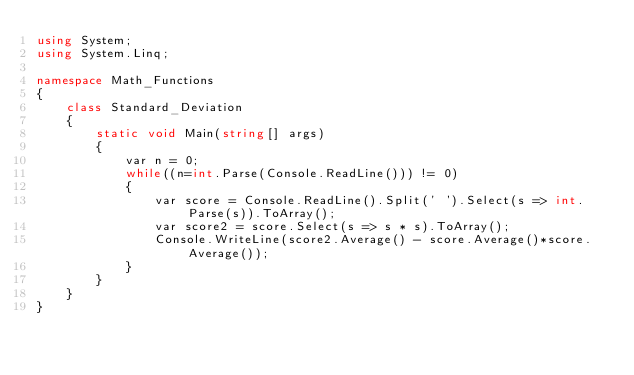<code> <loc_0><loc_0><loc_500><loc_500><_C#_>using System;
using System.Linq;

namespace Math_Functions
{
    class Standard_Deviation
    {
        static void Main(string[] args)
        {
            var n = 0;
            while((n=int.Parse(Console.ReadLine())) != 0)
            {
                var score = Console.ReadLine().Split(' ').Select(s => int.Parse(s)).ToArray();
                var score2 = score.Select(s => s * s).ToArray();
                Console.WriteLine(score2.Average() - score.Average()*score.Average());
            }
        }
    }
}</code> 